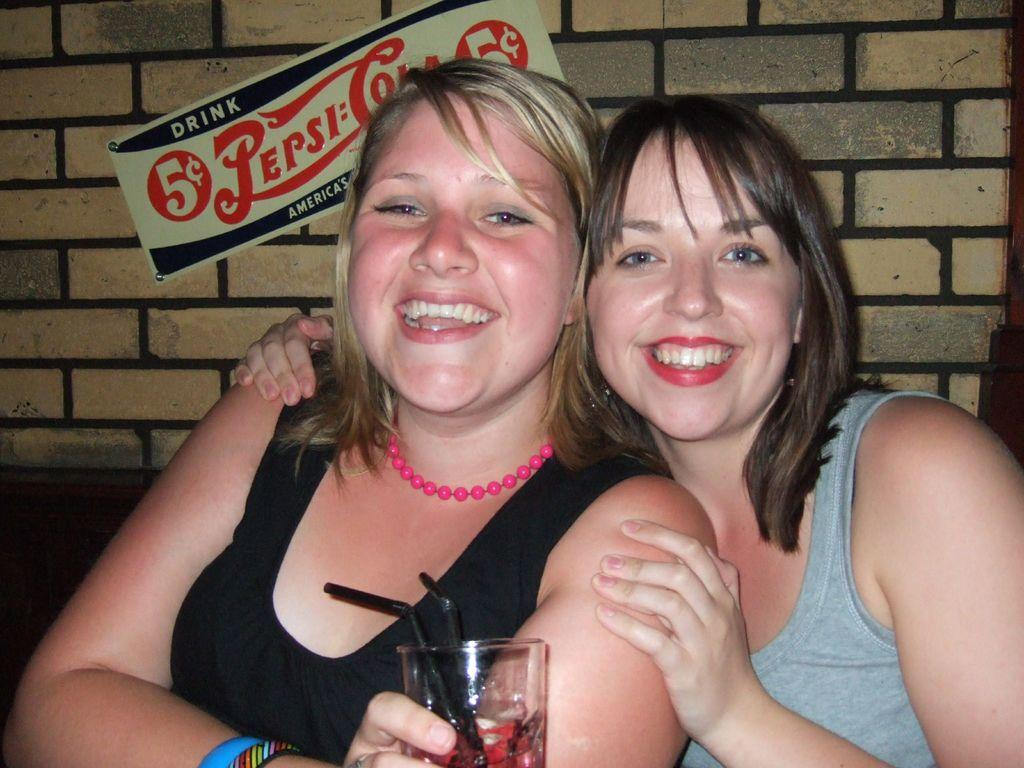How many people are in the image? There are two people in the image. What are the people doing in the image? The people are smiling in the image. What is one person holding in the image? One person is holding a glass in the image. What can be seen on the wall in the background? There is a board attached to a wall in the background. What type of noise can be heard coming from the door in the image? There is no door present in the image, so it's not possible to determine what, if any, noise might be heard. 